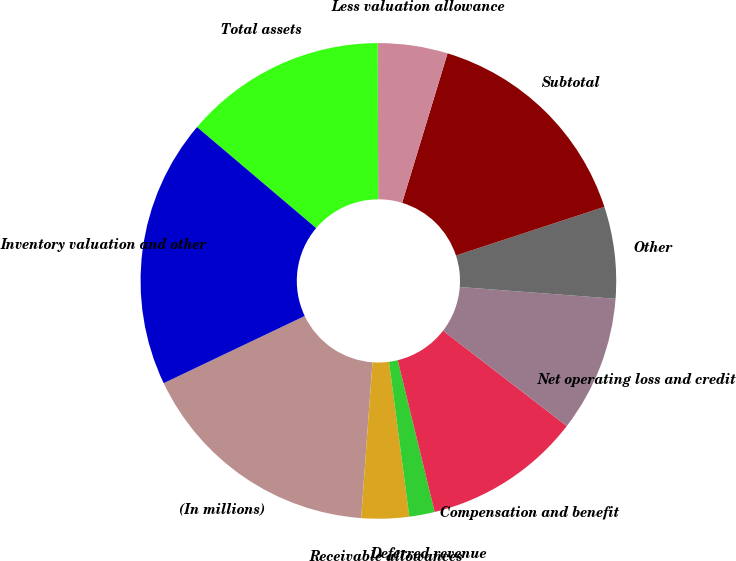Convert chart. <chart><loc_0><loc_0><loc_500><loc_500><pie_chart><fcel>(In millions)<fcel>Receivable allowances<fcel>Deferred revenue<fcel>Compensation and benefit<fcel>Net operating loss and credit<fcel>Other<fcel>Subtotal<fcel>Less valuation allowance<fcel>Total assets<fcel>Inventory valuation and other<nl><fcel>16.77%<fcel>3.23%<fcel>1.73%<fcel>10.75%<fcel>9.25%<fcel>6.24%<fcel>15.26%<fcel>4.74%<fcel>13.76%<fcel>18.27%<nl></chart> 